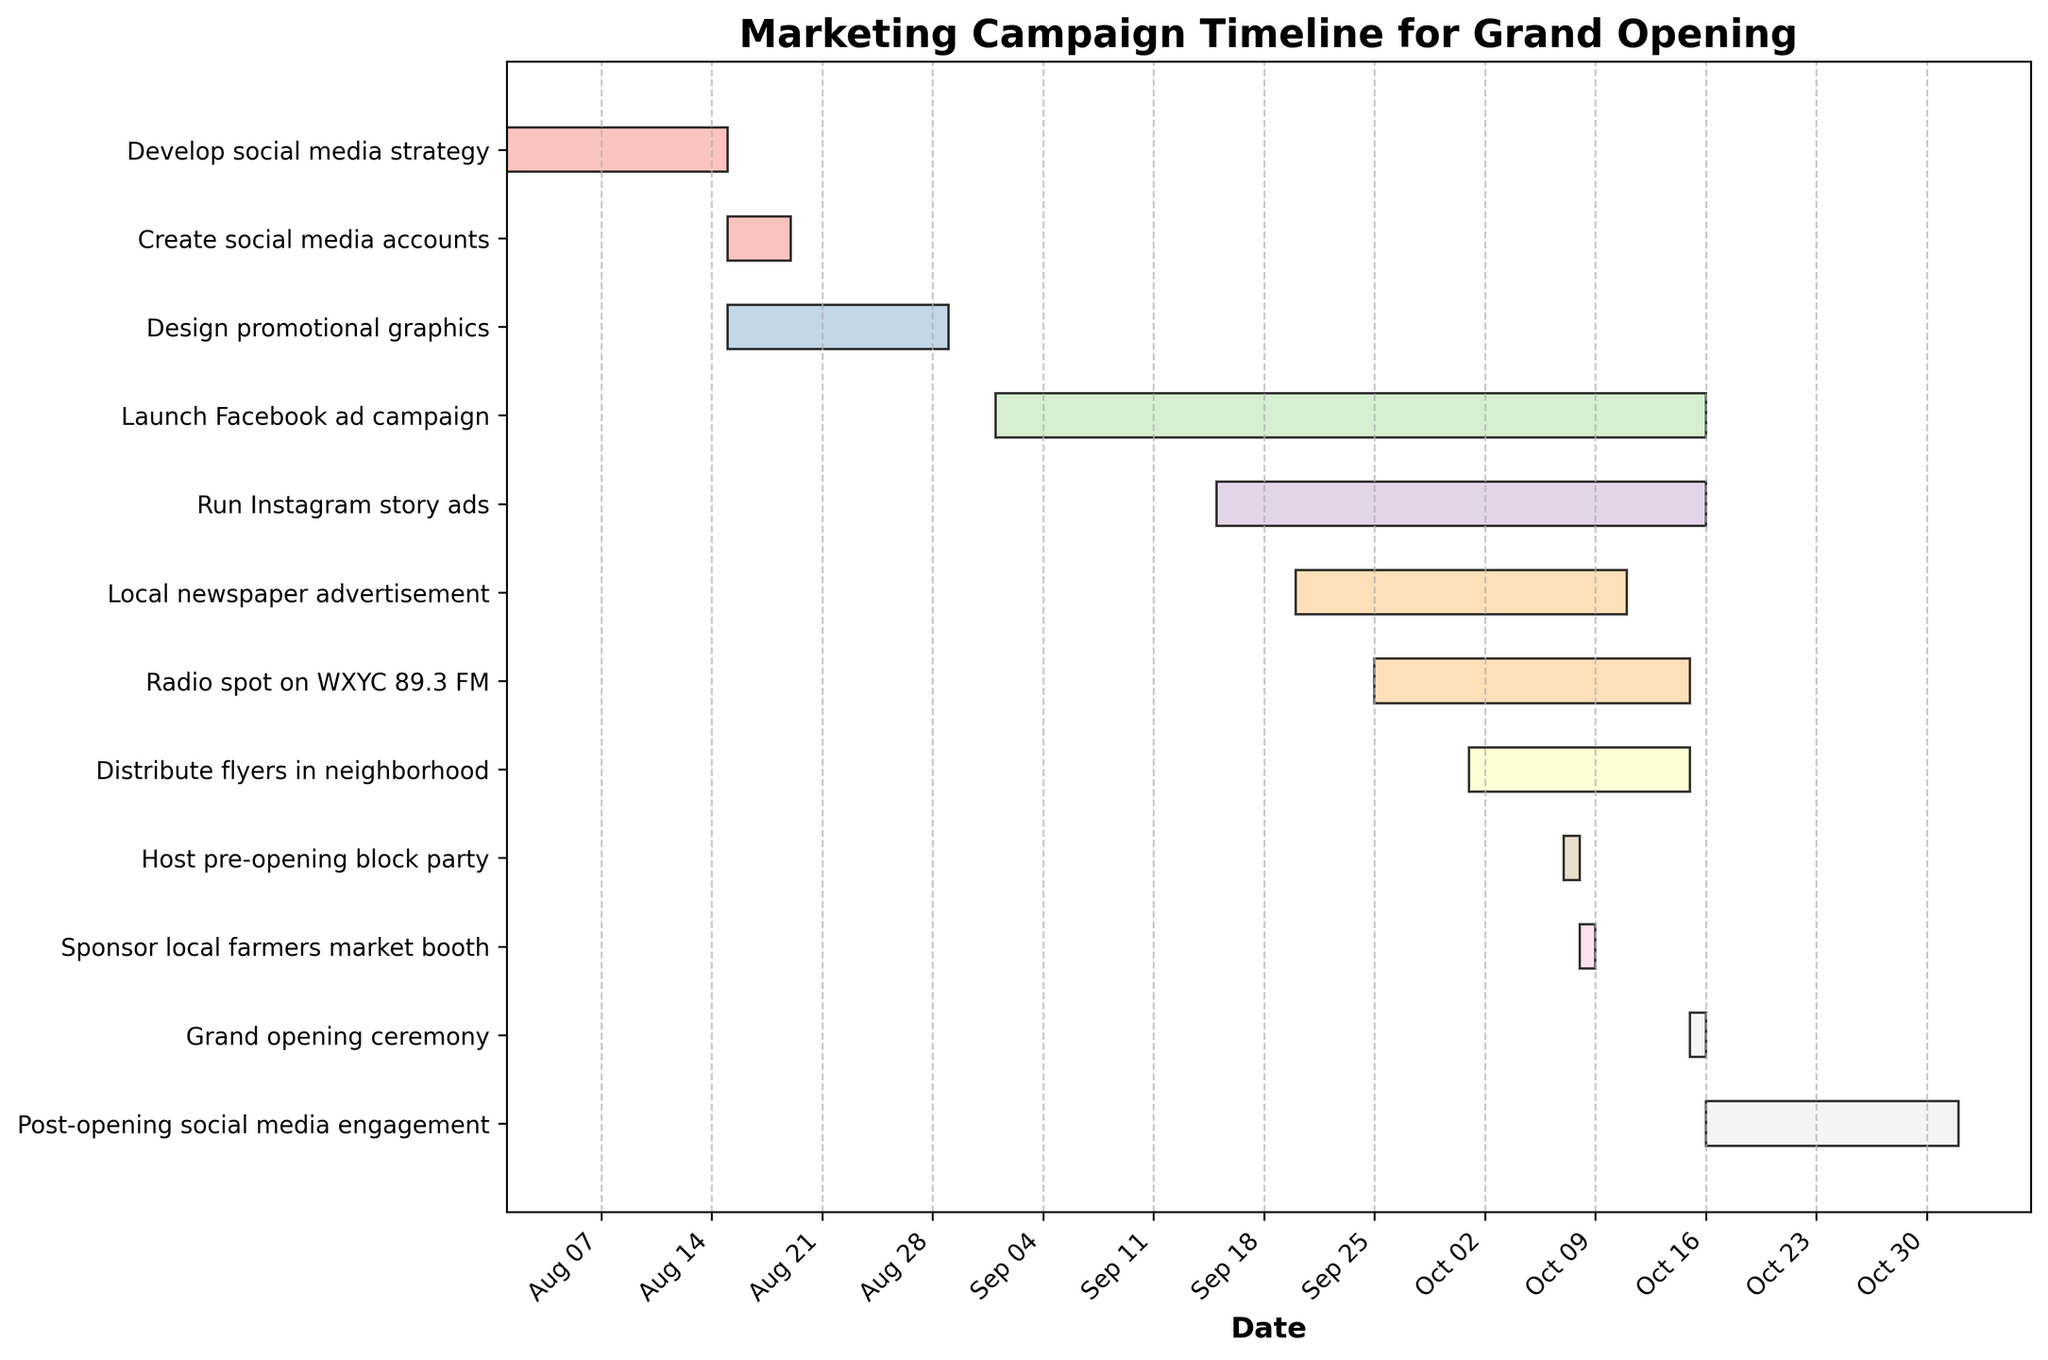what is the title of the figure? The title of the figure can be found at the top part of the chart. It provides a summary of what the chart is displaying. In this figure, the title is "Marketing Campaign Timeline for Grand Opening" which indicates the content and purpose of the Gantt Chart.
Answer: Marketing Campaign Timeline for Grand Opening When does the "Develop social media strategy" task start and end? To find the start and end dates for "Develop social media strategy," locate the corresponding bar in the Gantt Chart. The task starts on 2023-08-01 and ends on 2023-08-14.
Answer: 2023-08-01, 2023-08-14 How many days does the "Distribute flyers in neighborhood" task span? To calculate the duration of the "Distribute flyers in neighborhood" task, check the start date (2023-10-01) and end date (2023-10-14) on the chart. Subtracting the start date from the end date and adding one gives the task duration as 14 days.
Answer: 14 days Which tasks are ongoing during the first week of October? Look for bars that overlap with the first week of October (2023-10-01 to 2023-10-07). The tasks "Distribute flyers in neighborhood," and "Radio spot on WXYC 89.3 FM" are ongoing during this period.
Answer: Distribute flyers in neighborhood, Radio spot on WXYC 89.3 FM Compare the duration of the "Radio spot on WXYC 89.3 FM" and the "Local newspaper advertisement" tasks. Which one is longer? The duration of "Radio spot on WXYC 89.3 FM" (2023-09-25 to 2023-10-14) is 20 days and the "Local newspaper advertisement" (2023-09-20 to 2023-10-10) is 21 days. Therefore, the "Local newspaper advertisement" task is one day longer than the "Radio spot" task.
Answer: Local newspaper advertisement Are there any tasks that start and end on the same day? If so, name them. To find tasks that start and end on the same day, look for bars that cover just one date. The "Host pre-opening block party" and "Sponsor local farmers market booth" tasks both start and end on 2023-10-07 and 2023-10-08 respectively.
Answer: Host pre-opening block party, Sponsor local farmers market booth Which tasks are involved in social media activities? Identify the tasks related to social media by their description. These include "Develop social media strategy," "Create social media accounts," "Design promotional graphics," "Launch Facebook ad campaign," "Run Instagram story ads," and "Post-opening social media engagement."
Answer: Develop social media strategy, Create social media accounts, Design promotional graphics, Launch Facebook ad campaign, Run Instagram story ads, Post-opening social media engagement What are the tasks scheduled to end on October 15, 2023? Find tasks with an end date of October 15, 2023. These tasks are "Launch Facebook ad campaign," "Run Instagram story ads," and "Grand opening ceremony."
Answer: Launch Facebook ad campaign, Run Instagram story ads, Grand opening ceremony Which task has the shortest duration and what is its duration? To determine the shortest duration task, compare the length of all task bars. The "Host pre-opening block party" task and "Sponsor local farmers market booth" are the shortest, each lasting only one day.
Answer: Host pre-opening block party, Sponsor local farmers market booth Is there any overlap between the "Launch Facebook ad campaign" and "Run Instagram story ads" tasks? Check the durations of both tasks to see if they overlap. The "Launch Facebook ad campaign" runs from 2023-09-01 to 2023-10-15 and the "Run Instagram story ads" runs from 2023-09-15 to 2023-10-15, so they overlap significantly.
Answer: Yes 